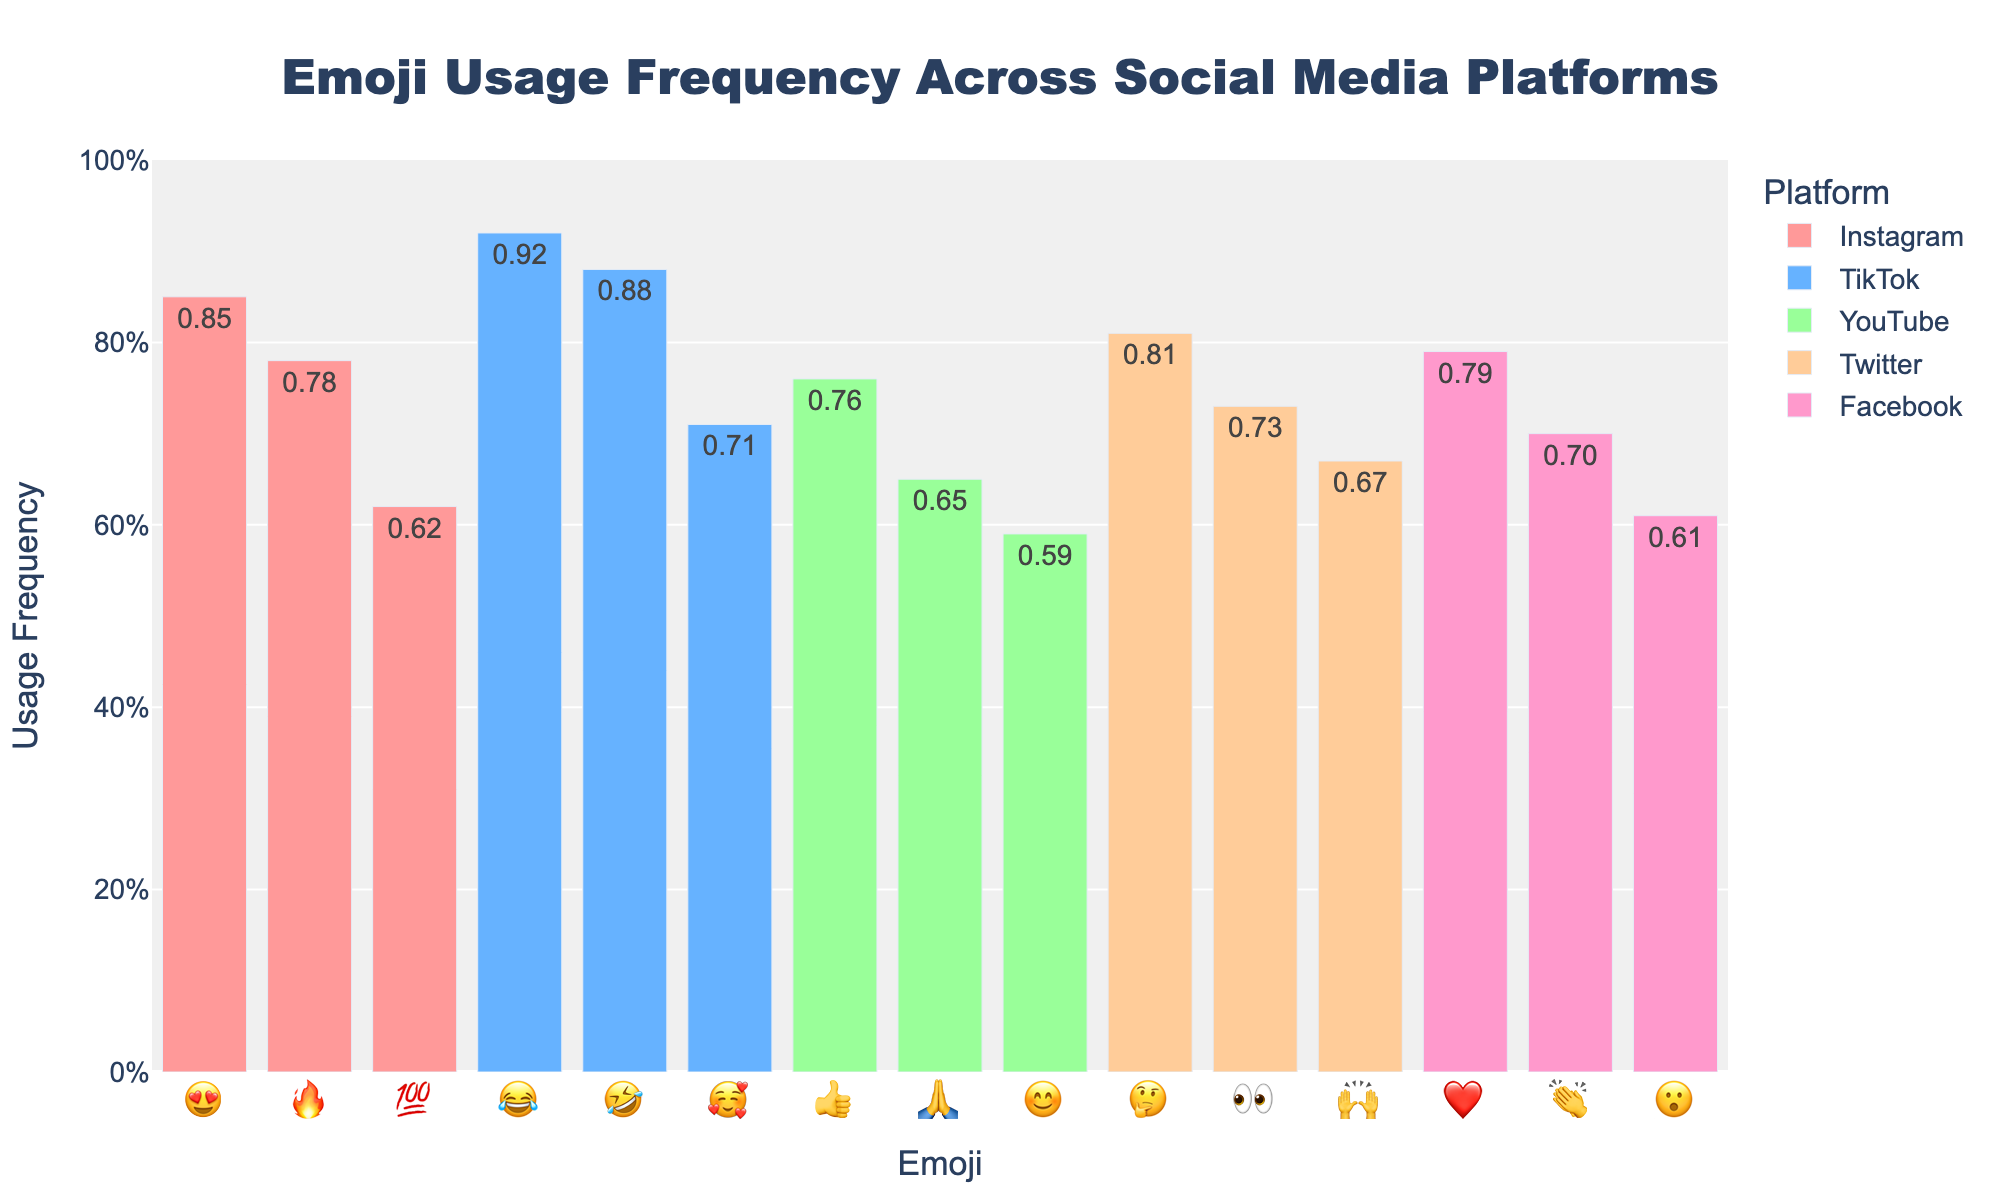What is the most frequently used emoji on Instagram? The bar representing '😍' on Instagram indicates a frequency of 0.85, the highest among the emojis for this platform, making it the most frequently used.
Answer: 😍 Which platform has the highest usage frequency for the emoji '😂'? By examining the bars representing '😂' across platforms, TikTok shows a frequency of 0.92, which is the highest.
Answer: TikTok Compare the usage frequency of the emoji '❤️' on Facebook with '👍' on YouTube. Which one is higher? '❤️' on Facebook has a frequency of 0.79, while '👍' on YouTube has 0.76. '❤️' on Facebook is slightly higher.
Answer: ❤️ on Facebook What is the average usage frequency of the top 3 emojis on TikTok? Adding the frequencies for TikTok's top 3 emojis: 😂 (0.92), 🤣 (0.88), and 🥰 (0.71) gives a total of 2.51. Dividing by 3, the average is 0.84.
Answer: 0.84 Which emoji on Twitter has a usage frequency very close to '🙏' on YouTube? The bar for '🙏' on YouTube shows a frequency of 0.65. The closest frequency on Twitter is '🙌' at 0.67.
Answer: 🙌 How does the usage frequency of '🔥' on Instagram compare to '🤣' on TikTok? The '🔥' emoji on Instagram has a frequency of 0.78, and '🤣' on TikTok is higher with 0.88.
Answer: 🤣 on TikTok is higher Identify the platform where the emoji '👏' is used and provide its frequency. The bar for '👏' appears on Facebook with a usage frequency of 0.70.
Answer: Facebook, 0.70 What is the total usage frequency for the emojis '😮', '👍', and '👀' across their respective platforms? Summing the frequencies: '😮' on Facebook (0.61) + '👍' on YouTube (0.76) + '👀' on Twitter (0.73) equals 2.10.
Answer: 2.10 